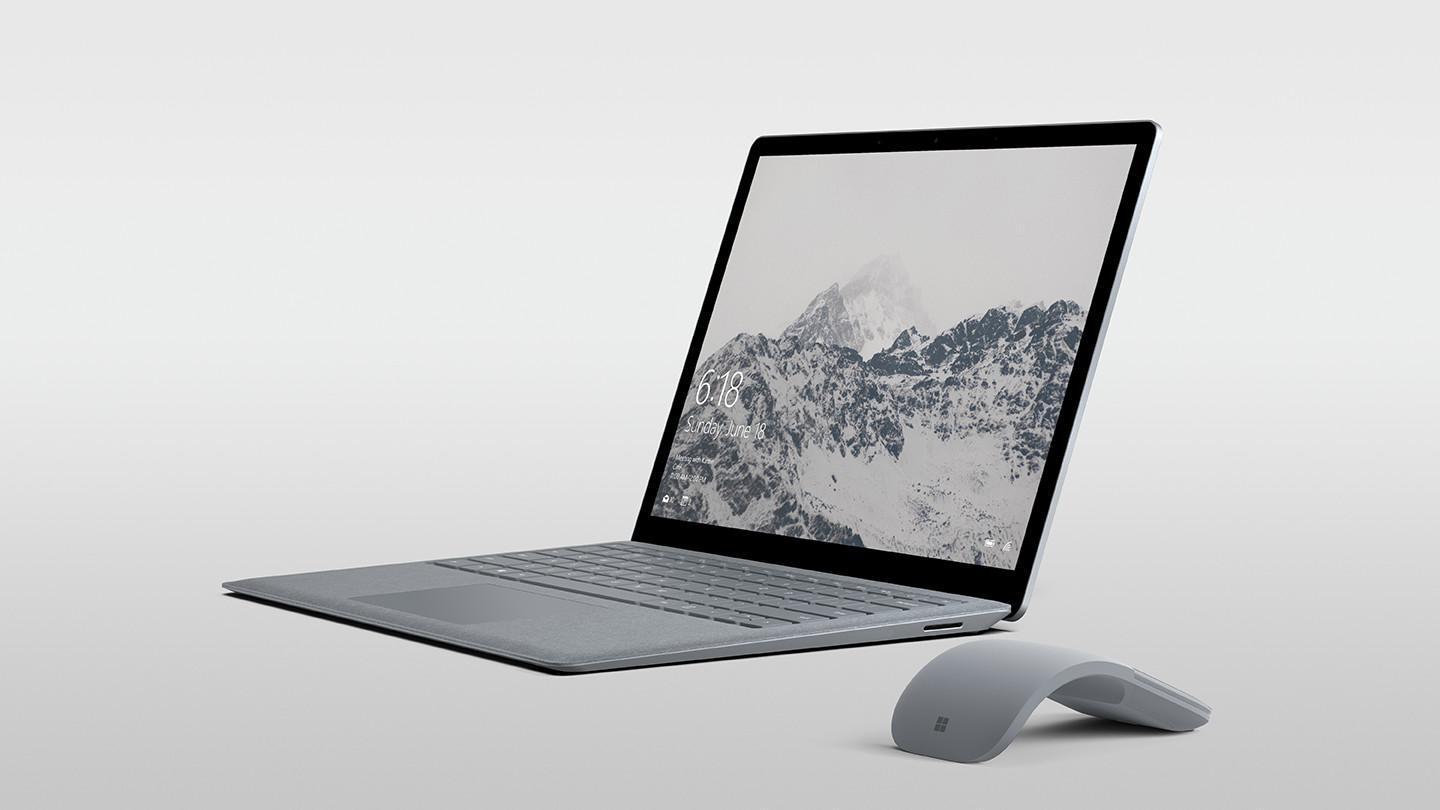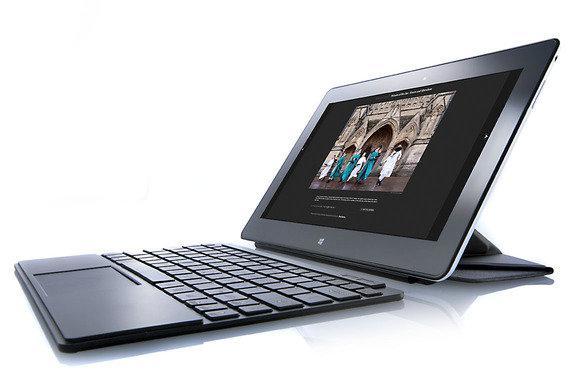The first image is the image on the left, the second image is the image on the right. Considering the images on both sides, is "In at least one image there is a silver bottomed laptop with a detachable mouse to the right." valid? Answer yes or no. Yes. The first image is the image on the left, the second image is the image on the right. Given the left and right images, does the statement "One image shows an open laptop with its keyboard base attached and sitting flat, and the other image includes at least one screen propped up like an easel with a keyboard in front of it that does not appear to be attached." hold true? Answer yes or no. Yes. 